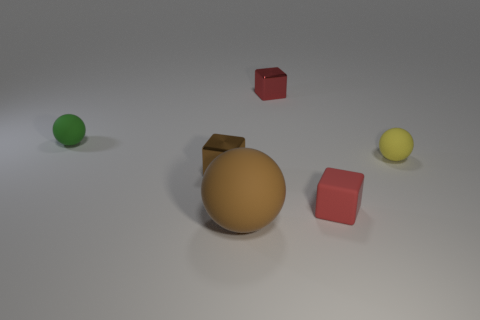How many other yellow matte things have the same shape as the yellow matte object?
Offer a very short reply. 0. There is a small red object that is the same material as the brown block; what is its shape?
Give a very brief answer. Cube. What is the material of the red object that is in front of the red block behind the small metallic object on the left side of the brown rubber thing?
Offer a terse response. Rubber. Does the red metal object have the same size as the matte sphere behind the yellow matte sphere?
Offer a terse response. Yes. There is a big thing that is the same shape as the tiny green rubber thing; what is it made of?
Your answer should be very brief. Rubber. There is a ball that is in front of the small cube that is in front of the brown metal cube to the left of the red matte thing; what size is it?
Ensure brevity in your answer.  Large. Do the brown metal cube and the green object have the same size?
Your answer should be very brief. Yes. Are there the same number of brown metallic blocks and tiny objects?
Your response must be concise. No. There is a brown object that is to the left of the rubber sphere in front of the tiny brown metal block; what is it made of?
Your answer should be very brief. Metal. Does the tiny green thing that is on the left side of the brown matte sphere have the same shape as the small red object that is behind the yellow ball?
Offer a terse response. No. 